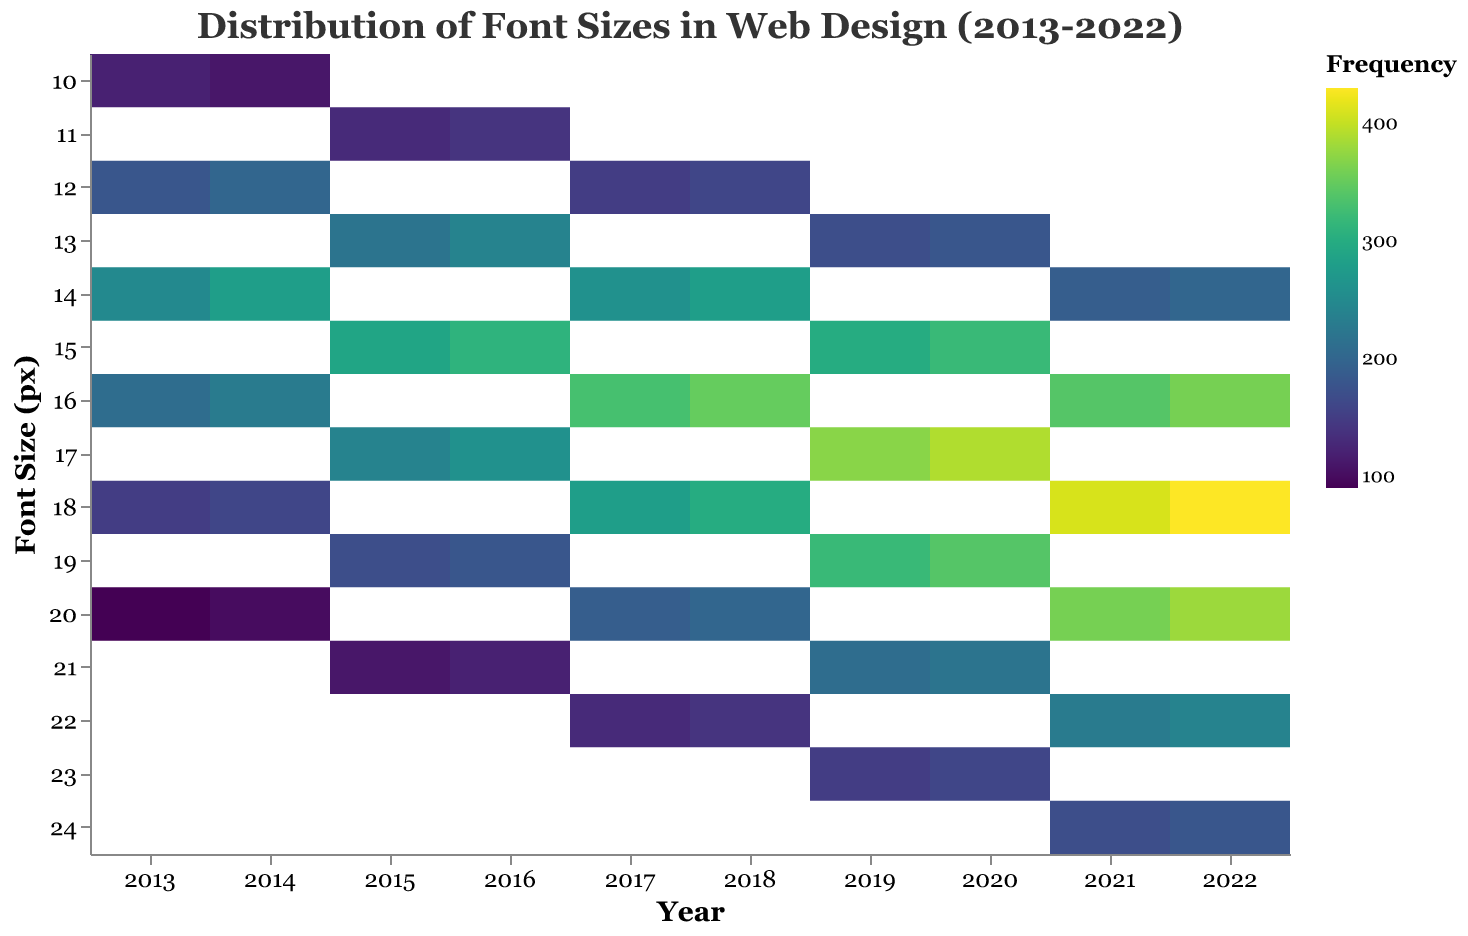What's the title of the figure? According to the provided code, the title of the figure is "Distribution of Font Sizes in Web Design (2013-2022)", which is specified in the "title" section.
Answer: Distribution of Font Sizes in Web Design (2013-2022) What does the x-axis represent? The x-axis is labeled as "Year", indicating it represents different years from 2013 to 2022. This information is provided under the "axis" section for the x encoding.
Answer: Year What does the y-axis represent? The y-axis is labeled as "Font Size (px)", which means it represents the font sizes in pixels.
Answer: Font Size (px) What color scheme is used to indicate frequency? The color scheme used is "viridis", which is a type of color scale specified in the color encoding section.
Answer: viridis In which year was the font size of 18 pixels most frequent? According to the data and the colors representing frequency in the plot, the most frequent font size of 18 pixels occurred in 2022.
Answer: 2022 Between 2013 and 2016, which year had the highest frequency for font size 14 pixels? The data shows the increment in frequency for font size 14 across these years; for 2016, the frequency is 310, which is higher than the frequencies for 2013, 2014, and 2015.
Answer: 2016 Which font size saw the largest increase in frequency from 2013 to 2022? Observing the trends in the hexbin for each font size's frequency over the years, font size 18 pixels shows the greatest increase, going from 150 in 2013 to 430 in 2022.
Answer: Font Size 18 Compare the frequency of the font size 16 pixels in 2014 and 2018. Which year had a higher frequency? By comparing the frequency values of 230 in 2014 and 350 in 2018 for the font size 16 pixels, it is clear that 2018 had a higher frequency.
Answer: 2018 What trend is visible for the frequency of font size 12 pixels from 2013 to 2018? By analyzing the data, font size 12 pixels shows an increasing trend in frequency from 2013 (180) to 2018 (160), but the increase is not consistent, with a slight dip in 2015 (130).
Answer: Increasing with minor fluctuations What range of font sizes became more popular from 2019 to 2022? Observing the plot, the font sizes ranging from 14 to 24 pixels gained popularity with increasing frequency from 2019 to 2022, indicated by the darker color areas within that range.
Answer: 14 to 24 pixels 